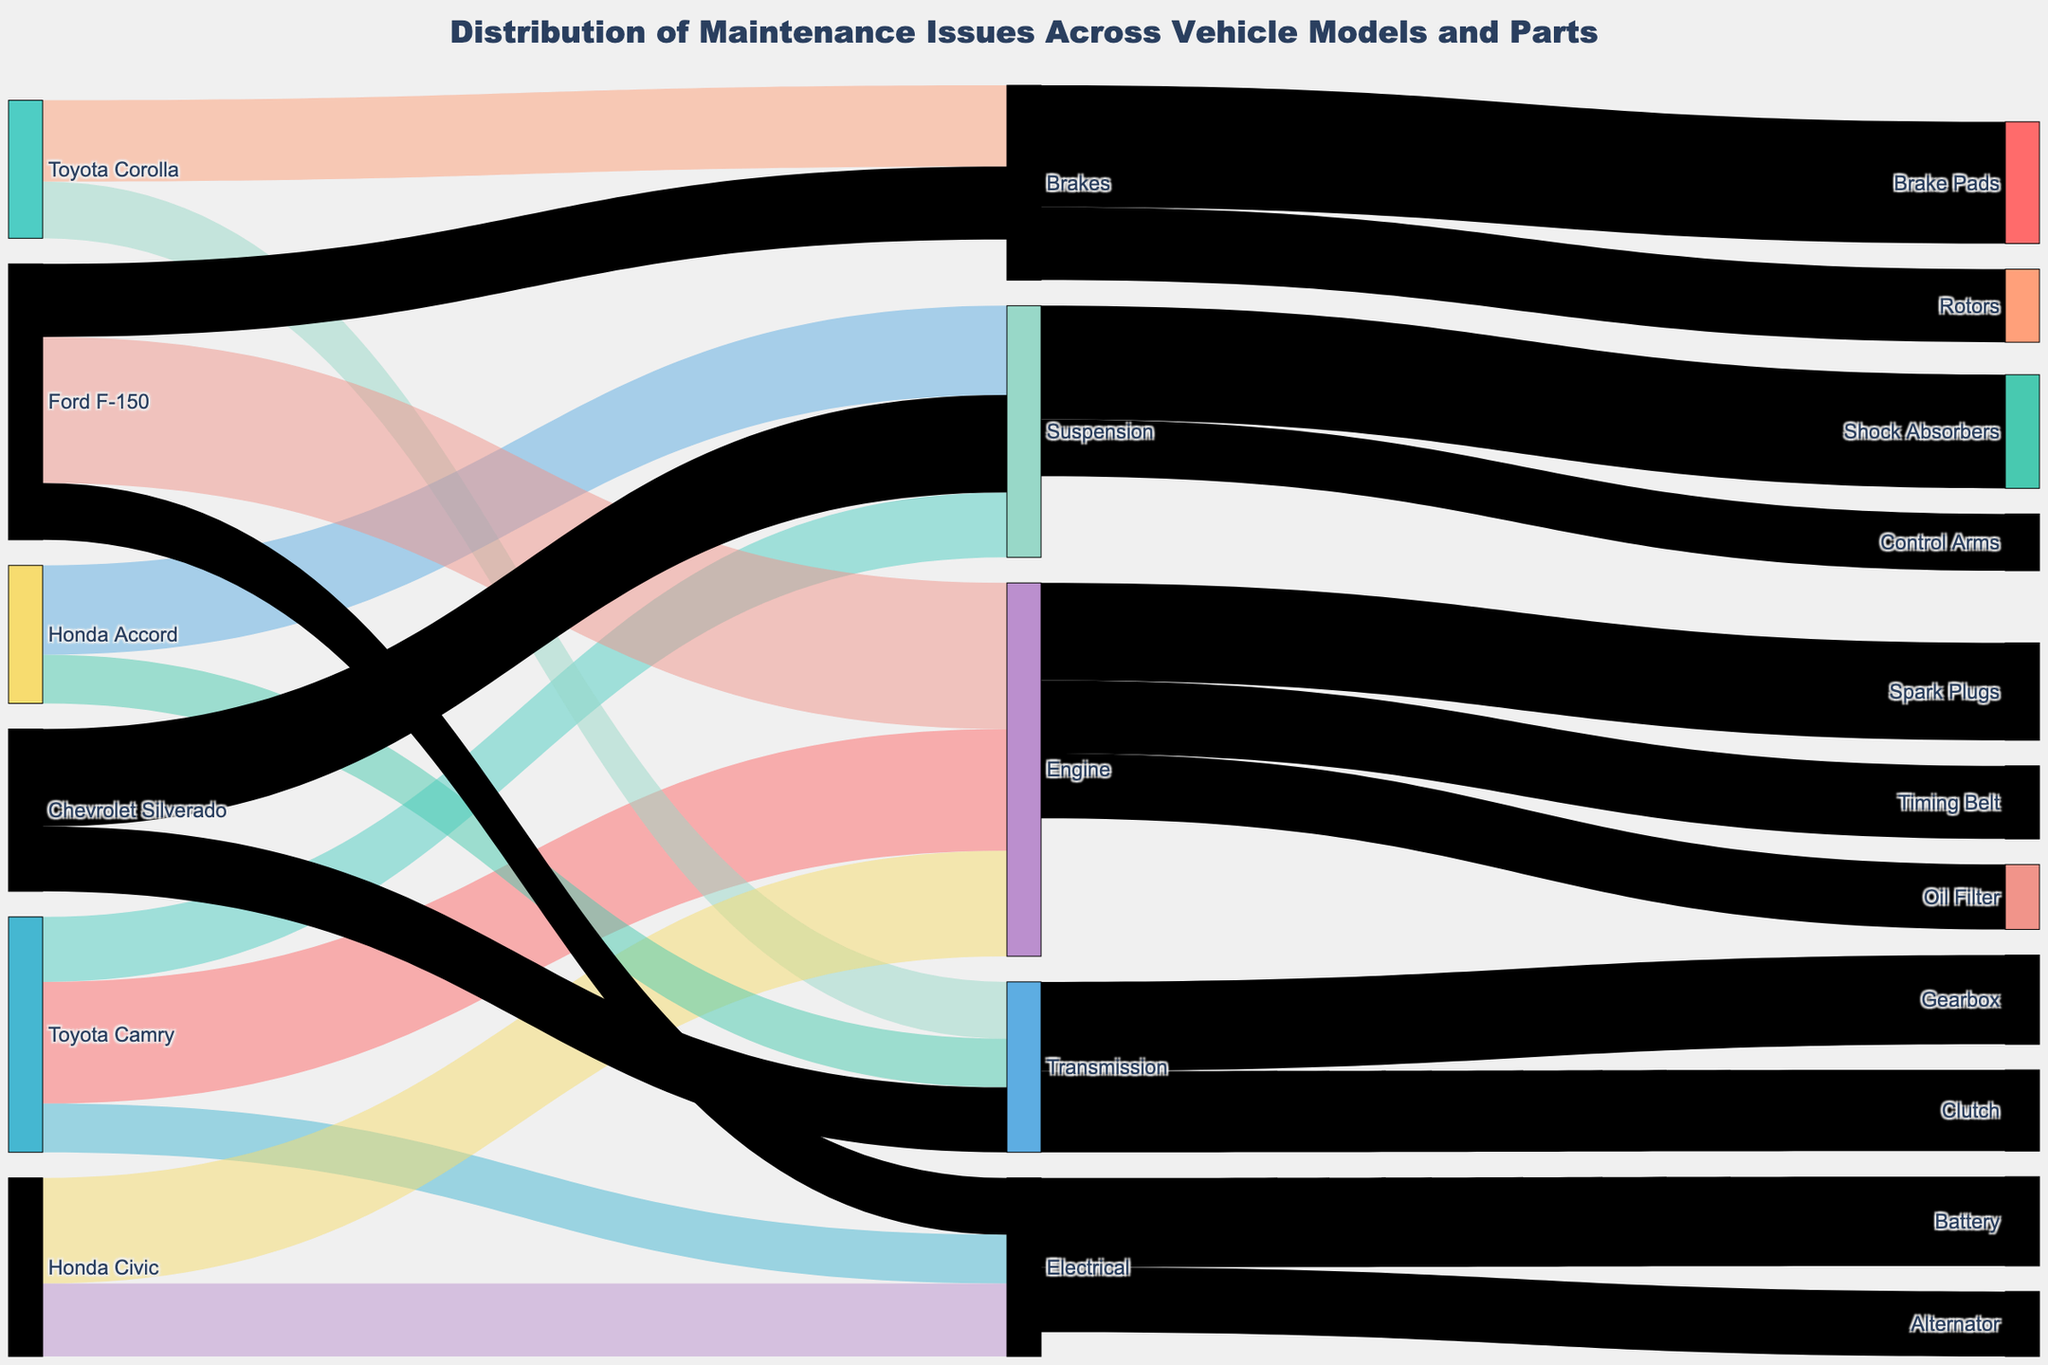What is the title of the figure? The title of the figure is usually located at the top and it gives a brief summary of what the figure represents. Here, it says: "Distribution of Maintenance Issues Across Vehicle Models and Parts."
Answer: Distribution of Maintenance Issues Across Vehicle Models and Parts Which vehicle model has the highest number of maintenance issues related to the engine? Look for the node representing "Engine" and trace its incoming connections from the vehicle models. Identify and compare the values. The vehicle with the highest value connected to the "Engine" node is the answer.
Answer: Ford F-150 How many maintenance issues related to the suspension does the Chevrolet Silverado have? Locate the node representing "Chevrolet Silverado" and follow its connection to the "Suspension" node. The value on this link represents the number of issues.
Answer: 120 Which part has the highest number of associated maintenance issues? Identify all the parts and sum the values of incoming connections for each part. The part with the highest total value has the most issues. Calculate for each part: Engine (150+130+180), Suspension (80+110+120), Electrical (60+90+70), Brakes (100+90), Transmission (70+60+80).
Answer: Engine How do the number of engine-related issues in Toyota Camry compare to those in Honda Civic? Locate the connections from "Toyota Camry" and "Honda Civic" to "Engine" and compare the values of these connections.
Answer: Toyota Camry has 150, Honda Civic has 130. Toyota Camry > Honda Civic What is the total number of maintenance issues related to the Brakes? Sum the values of all connections leading to the "Brakes" node from all the vehicle models. Here, Brakes (Toyota Corolla 100 + Ford F-150 90).
Answer: 190 Which vehicle model has the fewest total maintenance issues linked to its components? Calculate the total number of issues for each vehicle by summing the values of all outgoing connections from each vehicle node. Compare the totals: Toyota Camry (150+80+60), Toyota Corolla (100+70), Honda Civic (130+90), Honda Accord (110+60), Ford F-150 (180+70+90), Chevrolet Silverado (120+80).
Answer: Toyota Corolla What is the distribution of maintenance issues between oil filters, spark plugs, and timing belts for engines? Identify the connections from the "Engine" node to "Oil Filter," "Spark Plugs," and "Timing Belt," and note the values.
Answer: Oil Filter: 80, Spark Plugs: 120, Timing Belt: 90 